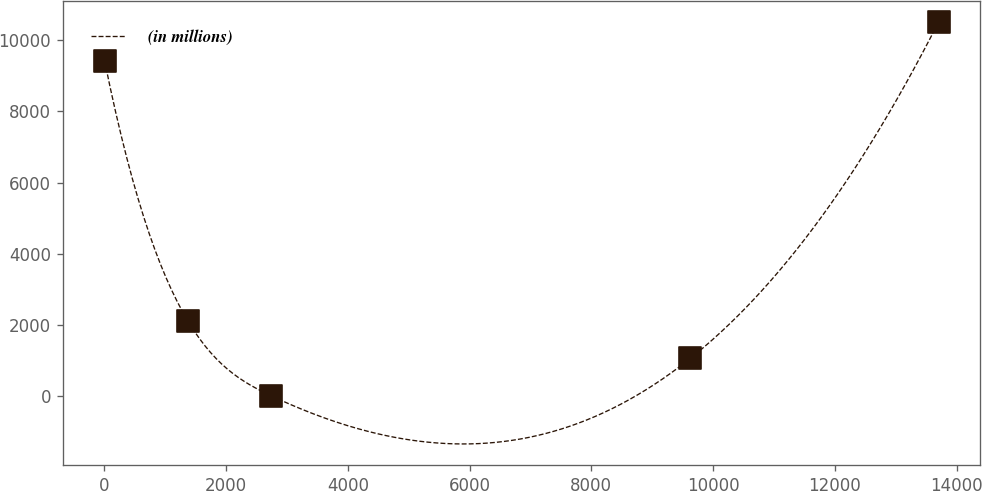<chart> <loc_0><loc_0><loc_500><loc_500><line_chart><ecel><fcel>(in millions)<nl><fcel>1.06<fcel>9425.34<nl><fcel>1371.44<fcel>2106.99<nl><fcel>2741.82<fcel>6.68<nl><fcel>9623.77<fcel>1056.84<nl><fcel>13704.8<fcel>10508.2<nl></chart> 